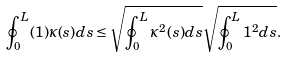Convert formula to latex. <formula><loc_0><loc_0><loc_500><loc_500>\oint _ { 0 } ^ { L } ( 1 ) \kappa ( s ) d s \leq \sqrt { \oint _ { 0 } ^ { L } \kappa ^ { 2 } ( s ) d s } \sqrt { \oint _ { 0 } ^ { L } 1 ^ { 2 } d s } .</formula> 